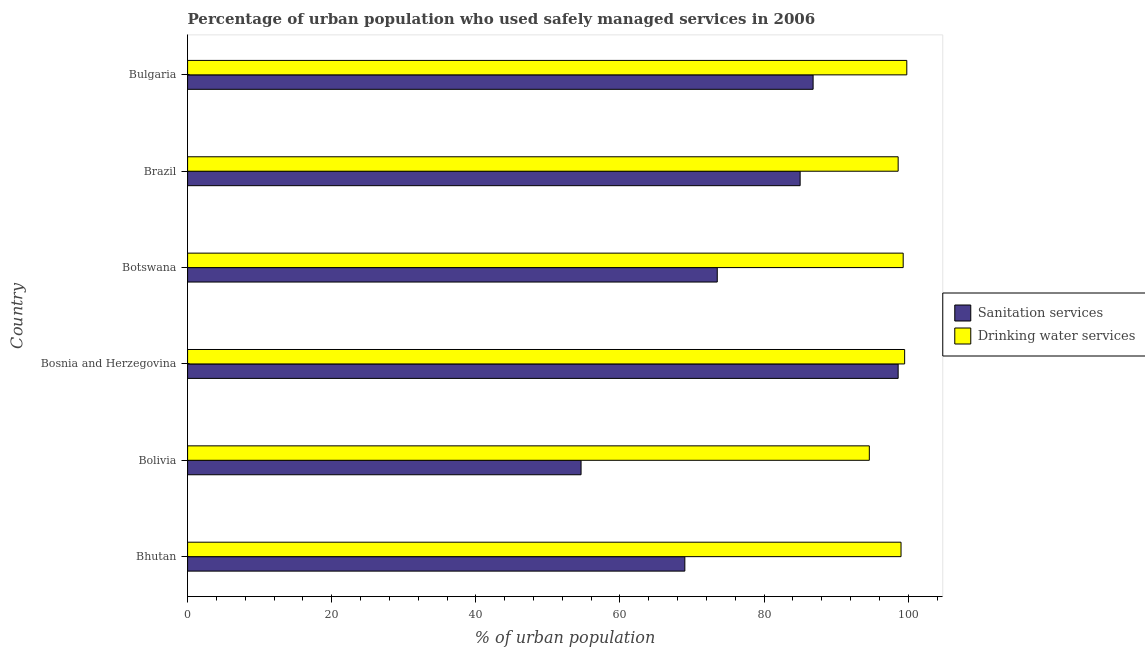Are the number of bars on each tick of the Y-axis equal?
Provide a short and direct response. Yes. What is the label of the 4th group of bars from the top?
Keep it short and to the point. Bosnia and Herzegovina. In how many cases, is the number of bars for a given country not equal to the number of legend labels?
Offer a very short reply. 0. What is the percentage of urban population who used drinking water services in Bolivia?
Ensure brevity in your answer.  94.6. Across all countries, what is the maximum percentage of urban population who used drinking water services?
Your answer should be compact. 99.8. Across all countries, what is the minimum percentage of urban population who used drinking water services?
Give a very brief answer. 94.6. In which country was the percentage of urban population who used sanitation services maximum?
Offer a terse response. Bosnia and Herzegovina. In which country was the percentage of urban population who used sanitation services minimum?
Your answer should be very brief. Bolivia. What is the total percentage of urban population who used sanitation services in the graph?
Keep it short and to the point. 467.5. What is the difference between the percentage of urban population who used drinking water services in Bhutan and the percentage of urban population who used sanitation services in Bolivia?
Ensure brevity in your answer.  44.4. What is the average percentage of urban population who used drinking water services per country?
Your response must be concise. 98.47. What is the difference between the percentage of urban population who used drinking water services and percentage of urban population who used sanitation services in Bhutan?
Your response must be concise. 30. What is the ratio of the percentage of urban population who used drinking water services in Bolivia to that in Bulgaria?
Your answer should be very brief. 0.95. Is the percentage of urban population who used drinking water services in Botswana less than that in Bulgaria?
Your response must be concise. Yes. What is the difference between the highest and the second highest percentage of urban population who used drinking water services?
Make the answer very short. 0.3. What is the difference between the highest and the lowest percentage of urban population who used sanitation services?
Your answer should be very brief. 44. What does the 1st bar from the top in Bulgaria represents?
Ensure brevity in your answer.  Drinking water services. What does the 1st bar from the bottom in Botswana represents?
Your response must be concise. Sanitation services. How many countries are there in the graph?
Your answer should be very brief. 6. What is the difference between two consecutive major ticks on the X-axis?
Offer a terse response. 20. Does the graph contain grids?
Your response must be concise. No. How many legend labels are there?
Ensure brevity in your answer.  2. What is the title of the graph?
Offer a very short reply. Percentage of urban population who used safely managed services in 2006. What is the label or title of the X-axis?
Ensure brevity in your answer.  % of urban population. What is the label or title of the Y-axis?
Your response must be concise. Country. What is the % of urban population in Sanitation services in Bolivia?
Give a very brief answer. 54.6. What is the % of urban population of Drinking water services in Bolivia?
Make the answer very short. 94.6. What is the % of urban population of Sanitation services in Bosnia and Herzegovina?
Provide a succinct answer. 98.6. What is the % of urban population in Drinking water services in Bosnia and Herzegovina?
Keep it short and to the point. 99.5. What is the % of urban population of Sanitation services in Botswana?
Your answer should be very brief. 73.5. What is the % of urban population of Drinking water services in Botswana?
Offer a very short reply. 99.3. What is the % of urban population in Drinking water services in Brazil?
Give a very brief answer. 98.6. What is the % of urban population of Sanitation services in Bulgaria?
Make the answer very short. 86.8. What is the % of urban population in Drinking water services in Bulgaria?
Provide a succinct answer. 99.8. Across all countries, what is the maximum % of urban population of Sanitation services?
Offer a very short reply. 98.6. Across all countries, what is the maximum % of urban population of Drinking water services?
Offer a very short reply. 99.8. Across all countries, what is the minimum % of urban population in Sanitation services?
Provide a short and direct response. 54.6. Across all countries, what is the minimum % of urban population in Drinking water services?
Offer a terse response. 94.6. What is the total % of urban population of Sanitation services in the graph?
Make the answer very short. 467.5. What is the total % of urban population in Drinking water services in the graph?
Offer a very short reply. 590.8. What is the difference between the % of urban population of Sanitation services in Bhutan and that in Bosnia and Herzegovina?
Keep it short and to the point. -29.6. What is the difference between the % of urban population in Sanitation services in Bhutan and that in Brazil?
Offer a very short reply. -16. What is the difference between the % of urban population in Drinking water services in Bhutan and that in Brazil?
Offer a terse response. 0.4. What is the difference between the % of urban population in Sanitation services in Bhutan and that in Bulgaria?
Provide a short and direct response. -17.8. What is the difference between the % of urban population in Drinking water services in Bhutan and that in Bulgaria?
Offer a terse response. -0.8. What is the difference between the % of urban population of Sanitation services in Bolivia and that in Bosnia and Herzegovina?
Keep it short and to the point. -44. What is the difference between the % of urban population of Sanitation services in Bolivia and that in Botswana?
Give a very brief answer. -18.9. What is the difference between the % of urban population of Sanitation services in Bolivia and that in Brazil?
Keep it short and to the point. -30.4. What is the difference between the % of urban population of Drinking water services in Bolivia and that in Brazil?
Offer a very short reply. -4. What is the difference between the % of urban population in Sanitation services in Bolivia and that in Bulgaria?
Offer a terse response. -32.2. What is the difference between the % of urban population in Drinking water services in Bolivia and that in Bulgaria?
Your answer should be very brief. -5.2. What is the difference between the % of urban population in Sanitation services in Bosnia and Herzegovina and that in Botswana?
Make the answer very short. 25.1. What is the difference between the % of urban population in Drinking water services in Bosnia and Herzegovina and that in Botswana?
Keep it short and to the point. 0.2. What is the difference between the % of urban population of Sanitation services in Bosnia and Herzegovina and that in Brazil?
Provide a succinct answer. 13.6. What is the difference between the % of urban population in Drinking water services in Bosnia and Herzegovina and that in Bulgaria?
Make the answer very short. -0.3. What is the difference between the % of urban population of Sanitation services in Botswana and that in Brazil?
Offer a terse response. -11.5. What is the difference between the % of urban population in Sanitation services in Botswana and that in Bulgaria?
Offer a terse response. -13.3. What is the difference between the % of urban population of Sanitation services in Bhutan and the % of urban population of Drinking water services in Bolivia?
Your answer should be very brief. -25.6. What is the difference between the % of urban population of Sanitation services in Bhutan and the % of urban population of Drinking water services in Bosnia and Herzegovina?
Your answer should be compact. -30.5. What is the difference between the % of urban population in Sanitation services in Bhutan and the % of urban population in Drinking water services in Botswana?
Keep it short and to the point. -30.3. What is the difference between the % of urban population in Sanitation services in Bhutan and the % of urban population in Drinking water services in Brazil?
Offer a very short reply. -29.6. What is the difference between the % of urban population in Sanitation services in Bhutan and the % of urban population in Drinking water services in Bulgaria?
Keep it short and to the point. -30.8. What is the difference between the % of urban population of Sanitation services in Bolivia and the % of urban population of Drinking water services in Bosnia and Herzegovina?
Your answer should be compact. -44.9. What is the difference between the % of urban population of Sanitation services in Bolivia and the % of urban population of Drinking water services in Botswana?
Offer a terse response. -44.7. What is the difference between the % of urban population of Sanitation services in Bolivia and the % of urban population of Drinking water services in Brazil?
Your answer should be compact. -44. What is the difference between the % of urban population of Sanitation services in Bolivia and the % of urban population of Drinking water services in Bulgaria?
Make the answer very short. -45.2. What is the difference between the % of urban population of Sanitation services in Bosnia and Herzegovina and the % of urban population of Drinking water services in Botswana?
Provide a succinct answer. -0.7. What is the difference between the % of urban population in Sanitation services in Bosnia and Herzegovina and the % of urban population in Drinking water services in Brazil?
Offer a very short reply. 0. What is the difference between the % of urban population of Sanitation services in Bosnia and Herzegovina and the % of urban population of Drinking water services in Bulgaria?
Give a very brief answer. -1.2. What is the difference between the % of urban population of Sanitation services in Botswana and the % of urban population of Drinking water services in Brazil?
Your response must be concise. -25.1. What is the difference between the % of urban population in Sanitation services in Botswana and the % of urban population in Drinking water services in Bulgaria?
Provide a short and direct response. -26.3. What is the difference between the % of urban population in Sanitation services in Brazil and the % of urban population in Drinking water services in Bulgaria?
Offer a terse response. -14.8. What is the average % of urban population in Sanitation services per country?
Offer a terse response. 77.92. What is the average % of urban population in Drinking water services per country?
Offer a very short reply. 98.47. What is the difference between the % of urban population of Sanitation services and % of urban population of Drinking water services in Bhutan?
Your response must be concise. -30. What is the difference between the % of urban population of Sanitation services and % of urban population of Drinking water services in Bosnia and Herzegovina?
Keep it short and to the point. -0.9. What is the difference between the % of urban population in Sanitation services and % of urban population in Drinking water services in Botswana?
Make the answer very short. -25.8. What is the difference between the % of urban population of Sanitation services and % of urban population of Drinking water services in Brazil?
Give a very brief answer. -13.6. What is the ratio of the % of urban population in Sanitation services in Bhutan to that in Bolivia?
Ensure brevity in your answer.  1.26. What is the ratio of the % of urban population of Drinking water services in Bhutan to that in Bolivia?
Your answer should be very brief. 1.05. What is the ratio of the % of urban population of Sanitation services in Bhutan to that in Bosnia and Herzegovina?
Your answer should be compact. 0.7. What is the ratio of the % of urban population in Drinking water services in Bhutan to that in Bosnia and Herzegovina?
Offer a terse response. 0.99. What is the ratio of the % of urban population of Sanitation services in Bhutan to that in Botswana?
Make the answer very short. 0.94. What is the ratio of the % of urban population in Sanitation services in Bhutan to that in Brazil?
Provide a short and direct response. 0.81. What is the ratio of the % of urban population of Drinking water services in Bhutan to that in Brazil?
Make the answer very short. 1. What is the ratio of the % of urban population in Sanitation services in Bhutan to that in Bulgaria?
Make the answer very short. 0.79. What is the ratio of the % of urban population of Sanitation services in Bolivia to that in Bosnia and Herzegovina?
Give a very brief answer. 0.55. What is the ratio of the % of urban population of Drinking water services in Bolivia to that in Bosnia and Herzegovina?
Your answer should be compact. 0.95. What is the ratio of the % of urban population of Sanitation services in Bolivia to that in Botswana?
Provide a short and direct response. 0.74. What is the ratio of the % of urban population in Drinking water services in Bolivia to that in Botswana?
Provide a short and direct response. 0.95. What is the ratio of the % of urban population in Sanitation services in Bolivia to that in Brazil?
Provide a short and direct response. 0.64. What is the ratio of the % of urban population in Drinking water services in Bolivia to that in Brazil?
Your response must be concise. 0.96. What is the ratio of the % of urban population of Sanitation services in Bolivia to that in Bulgaria?
Provide a succinct answer. 0.63. What is the ratio of the % of urban population of Drinking water services in Bolivia to that in Bulgaria?
Keep it short and to the point. 0.95. What is the ratio of the % of urban population in Sanitation services in Bosnia and Herzegovina to that in Botswana?
Provide a succinct answer. 1.34. What is the ratio of the % of urban population of Sanitation services in Bosnia and Herzegovina to that in Brazil?
Make the answer very short. 1.16. What is the ratio of the % of urban population in Drinking water services in Bosnia and Herzegovina to that in Brazil?
Provide a short and direct response. 1.01. What is the ratio of the % of urban population in Sanitation services in Bosnia and Herzegovina to that in Bulgaria?
Provide a succinct answer. 1.14. What is the ratio of the % of urban population in Drinking water services in Bosnia and Herzegovina to that in Bulgaria?
Ensure brevity in your answer.  1. What is the ratio of the % of urban population of Sanitation services in Botswana to that in Brazil?
Provide a short and direct response. 0.86. What is the ratio of the % of urban population of Drinking water services in Botswana to that in Brazil?
Your answer should be very brief. 1.01. What is the ratio of the % of urban population in Sanitation services in Botswana to that in Bulgaria?
Offer a terse response. 0.85. What is the ratio of the % of urban population in Drinking water services in Botswana to that in Bulgaria?
Your response must be concise. 0.99. What is the ratio of the % of urban population of Sanitation services in Brazil to that in Bulgaria?
Your response must be concise. 0.98. What is the difference between the highest and the lowest % of urban population in Sanitation services?
Provide a succinct answer. 44. What is the difference between the highest and the lowest % of urban population of Drinking water services?
Provide a succinct answer. 5.2. 